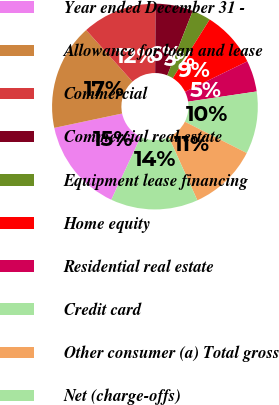<chart> <loc_0><loc_0><loc_500><loc_500><pie_chart><fcel>Year ended December 31 -<fcel>Allowance for loan and lease<fcel>Commercial<fcel>Commercial real estate<fcel>Equipment lease financing<fcel>Home equity<fcel>Residential real estate<fcel>Credit card<fcel>Other consumer (a) Total gross<fcel>Net (charge-offs)<nl><fcel>14.71%<fcel>16.67%<fcel>11.76%<fcel>5.88%<fcel>2.94%<fcel>8.82%<fcel>4.9%<fcel>9.8%<fcel>10.78%<fcel>13.73%<nl></chart> 